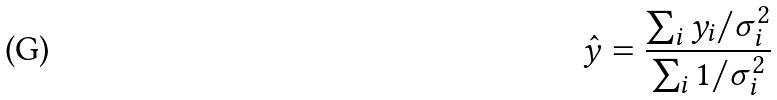<formula> <loc_0><loc_0><loc_500><loc_500>\hat { y } = \frac { \sum _ { i } y _ { i } / \sigma _ { i } ^ { 2 } } { \sum _ { i } 1 / \sigma _ { i } ^ { 2 } }</formula> 